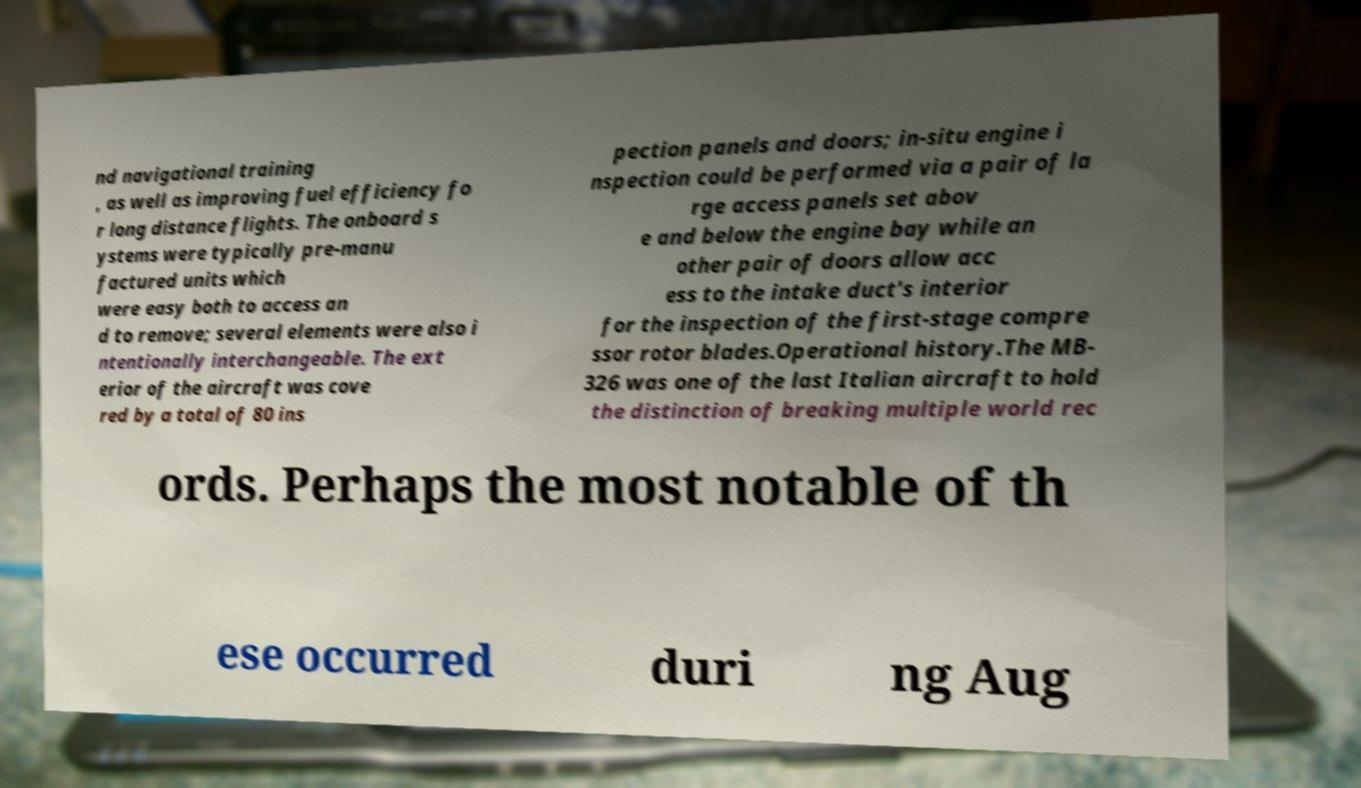What messages or text are displayed in this image? I need them in a readable, typed format. nd navigational training , as well as improving fuel efficiency fo r long distance flights. The onboard s ystems were typically pre-manu factured units which were easy both to access an d to remove; several elements were also i ntentionally interchangeable. The ext erior of the aircraft was cove red by a total of 80 ins pection panels and doors; in-situ engine i nspection could be performed via a pair of la rge access panels set abov e and below the engine bay while an other pair of doors allow acc ess to the intake duct's interior for the inspection of the first-stage compre ssor rotor blades.Operational history.The MB- 326 was one of the last Italian aircraft to hold the distinction of breaking multiple world rec ords. Perhaps the most notable of th ese occurred duri ng Aug 